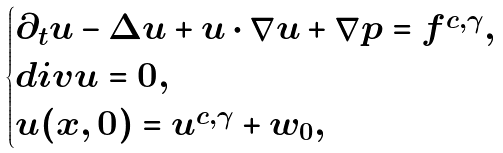Convert formula to latex. <formula><loc_0><loc_0><loc_500><loc_500>\begin{cases} \partial _ { t } u - \Delta u + u \cdot \nabla u + \nabla p = f ^ { c , \gamma } , \\ d i v u = 0 , \\ u ( x , 0 ) = u ^ { c , \gamma } + w _ { 0 } , \end{cases}</formula> 